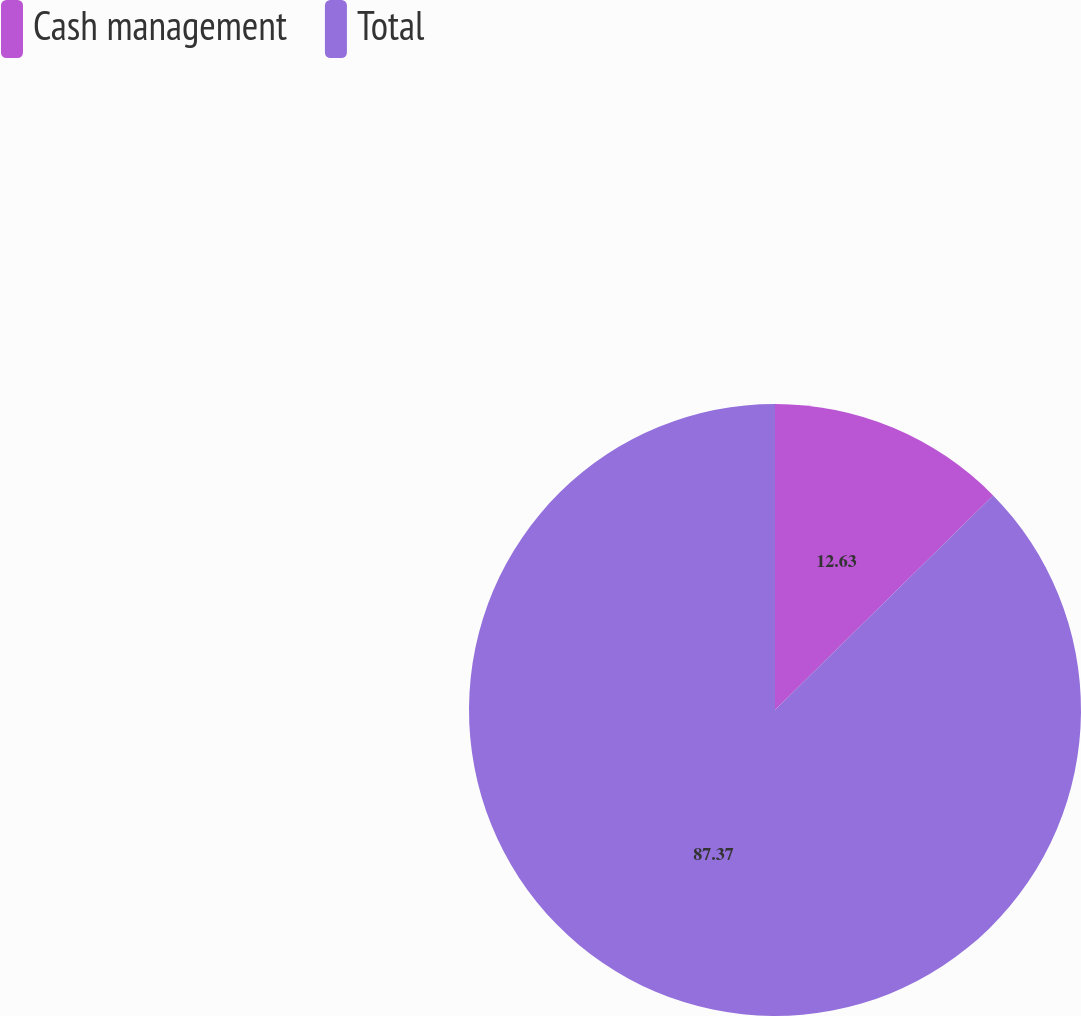Convert chart to OTSL. <chart><loc_0><loc_0><loc_500><loc_500><pie_chart><fcel>Cash management<fcel>Total<nl><fcel>12.63%<fcel>87.37%<nl></chart> 